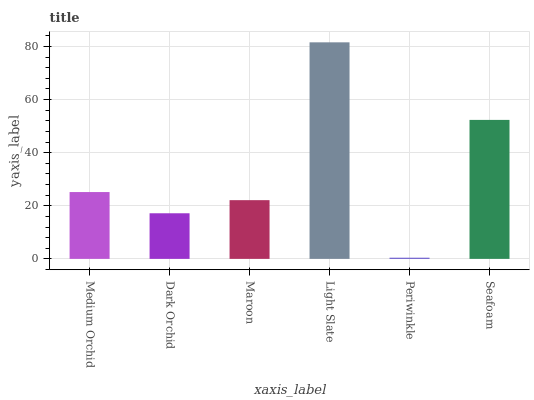Is Dark Orchid the minimum?
Answer yes or no. No. Is Dark Orchid the maximum?
Answer yes or no. No. Is Medium Orchid greater than Dark Orchid?
Answer yes or no. Yes. Is Dark Orchid less than Medium Orchid?
Answer yes or no. Yes. Is Dark Orchid greater than Medium Orchid?
Answer yes or no. No. Is Medium Orchid less than Dark Orchid?
Answer yes or no. No. Is Medium Orchid the high median?
Answer yes or no. Yes. Is Maroon the low median?
Answer yes or no. Yes. Is Seafoam the high median?
Answer yes or no. No. Is Dark Orchid the low median?
Answer yes or no. No. 